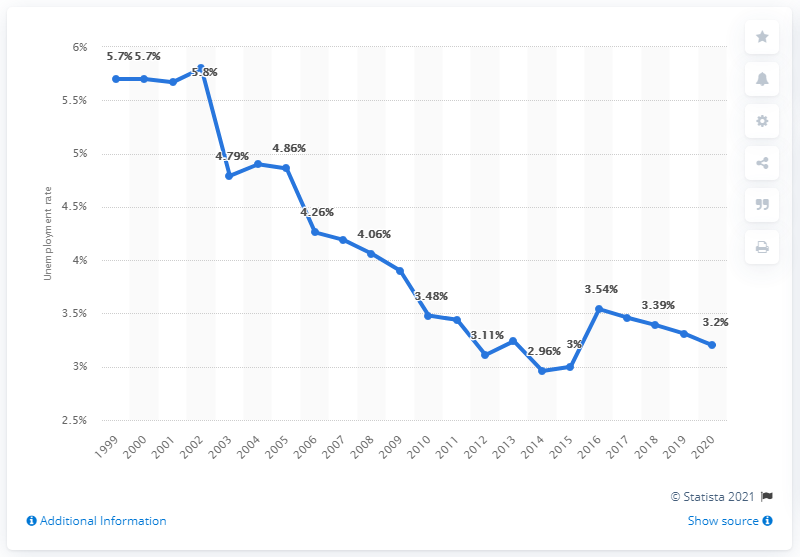Identify some key points in this picture. In 2020, the unemployment rate in Peru was 3.2%. 